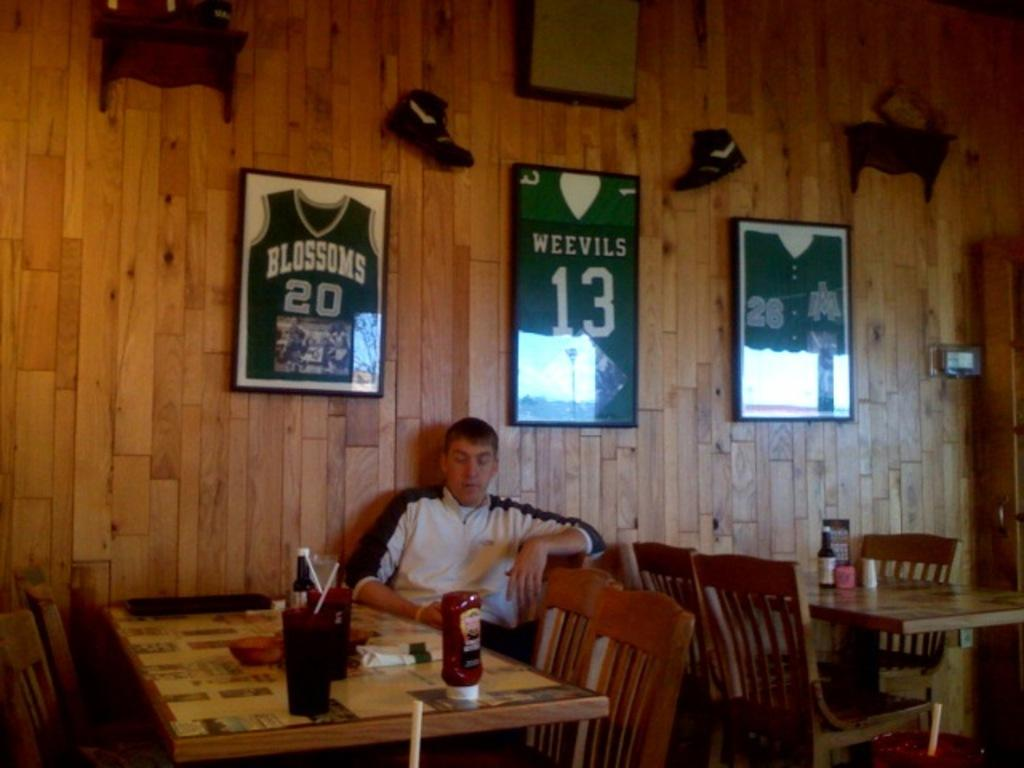What is the man in the image doing? The man is sitting on a chair in the image. What object is on the table in the image? There is a bottle on a table in the image. What can be seen in the background of the image? There is a frame and a wooden wall in the background of the image. What type of mist can be seen surrounding the man in the image? There is no mist present in the image; it is a clear scene with the man sitting on a chair. 